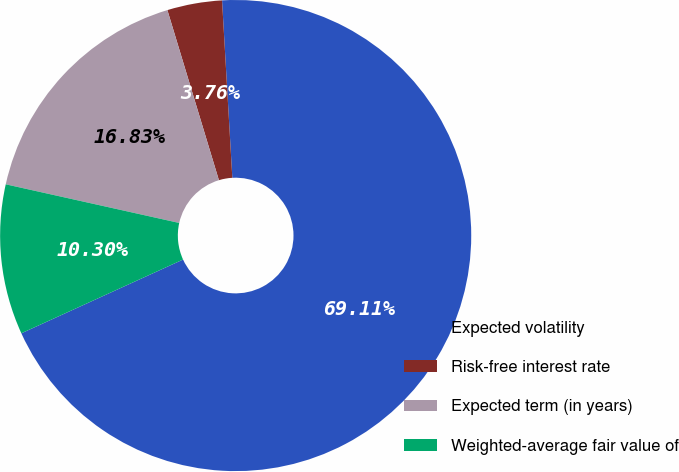<chart> <loc_0><loc_0><loc_500><loc_500><pie_chart><fcel>Expected volatility<fcel>Risk-free interest rate<fcel>Expected term (in years)<fcel>Weighted-average fair value of<nl><fcel>69.11%<fcel>3.76%<fcel>16.83%<fcel>10.3%<nl></chart> 